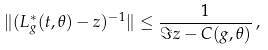Convert formula to latex. <formula><loc_0><loc_0><loc_500><loc_500>\| ( L ^ { * } _ { g } ( t , \theta ) - z ) ^ { - 1 } \| \leq \frac { 1 } { \Im z - C ( g , \theta ) } \, ,</formula> 